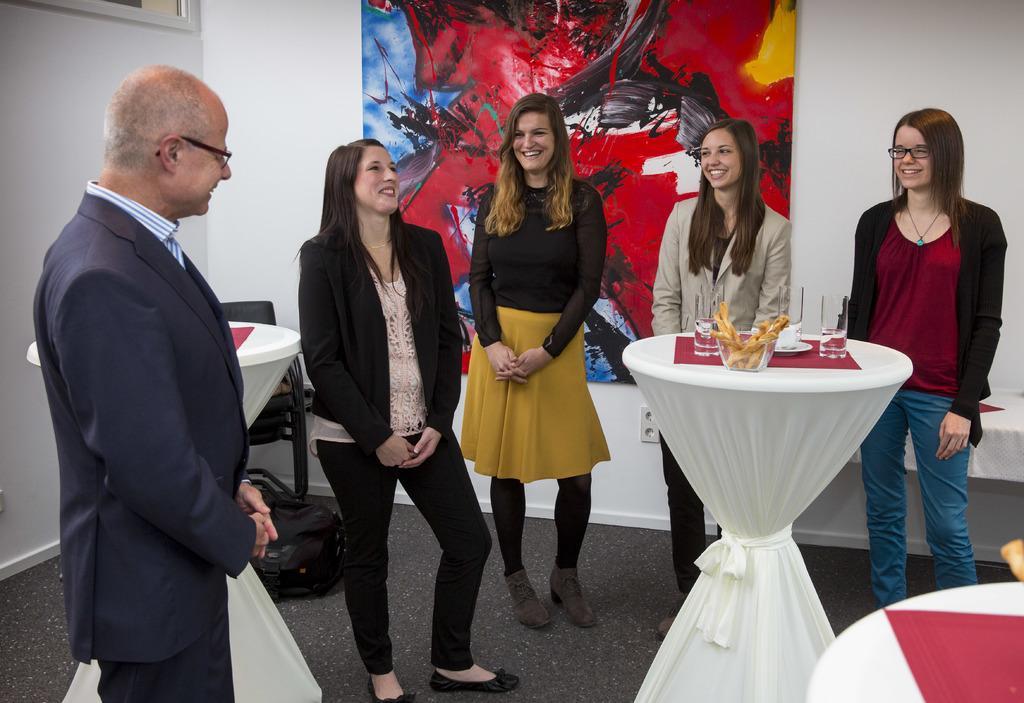In one or two sentences, can you explain what this image depicts? In this image we can see few people standing. Some are wearing specs. There are stands. On the stand there is a red color mat, glasses, bowl with food items and some other items. In the back there is a wall with a painting. In the back there are chairs. On the floor there is a mat. 